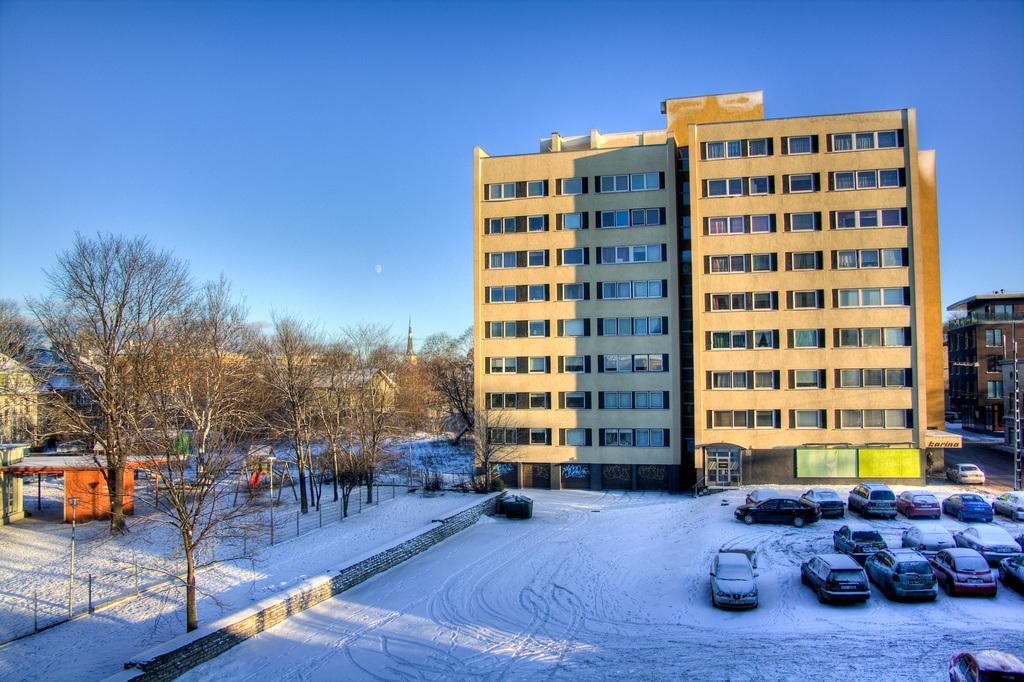What type of structures can be seen in the image? There are buildings in the image. What vehicles are present in the image? There are cars parked in the image. What type of vegetation is visible in the image? There are trees in the image. What weather condition is depicted in the image? There is snow visible in the image. What color is the sky in the image? The sky is blue in the image. Can you tell me how many yaks are pulling the truck in the image? There is no truck or yak present in the image. What is the temper of the person walking in the image? There is no person walking in the image, so their temper cannot be determined. 